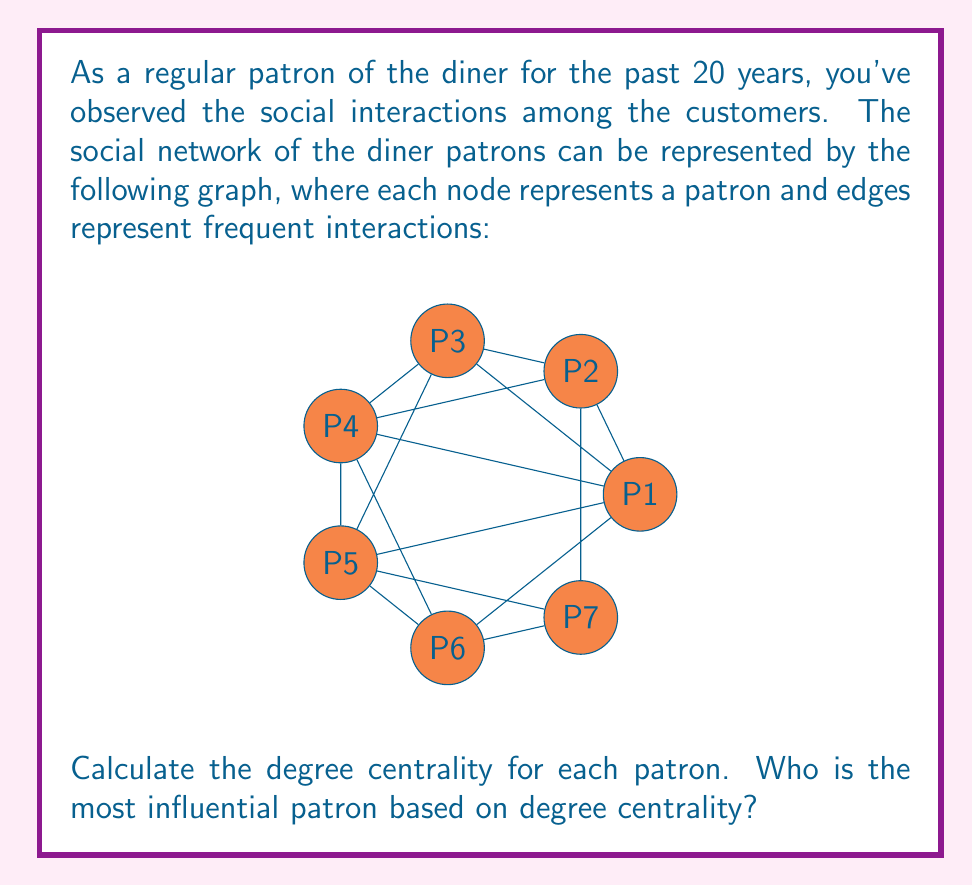Provide a solution to this math problem. To solve this problem, we need to follow these steps:

1) First, let's recall the definition of degree centrality. For an undirected graph, the degree centrality of a node is simply the number of edges connected to that node.

2) Now, let's count the number of edges connected to each patron:

   P1: 6 edges
   P2: 3 edges
   P3: 3 edges
   P4: 3 edges
   P5: 3 edges
   P6: 3 edges
   P7: 3 edges

3) The degree centrality is often normalized by dividing by the maximum possible degree (n-1, where n is the number of nodes). In this case, the maximum possible degree is 6.

4) So, the normalized degree centralities are:

   $C_D(P1) = \frac{6}{6} = 1$
   $C_D(P2) = C_D(P3) = C_D(P4) = C_D(P5) = C_D(P6) = C_D(P7) = \frac{3}{6} = 0.5$

5) The patron with the highest degree centrality is the most influential according to this measure.

Therefore, P1 is the most influential patron based on degree centrality.
Answer: P1 